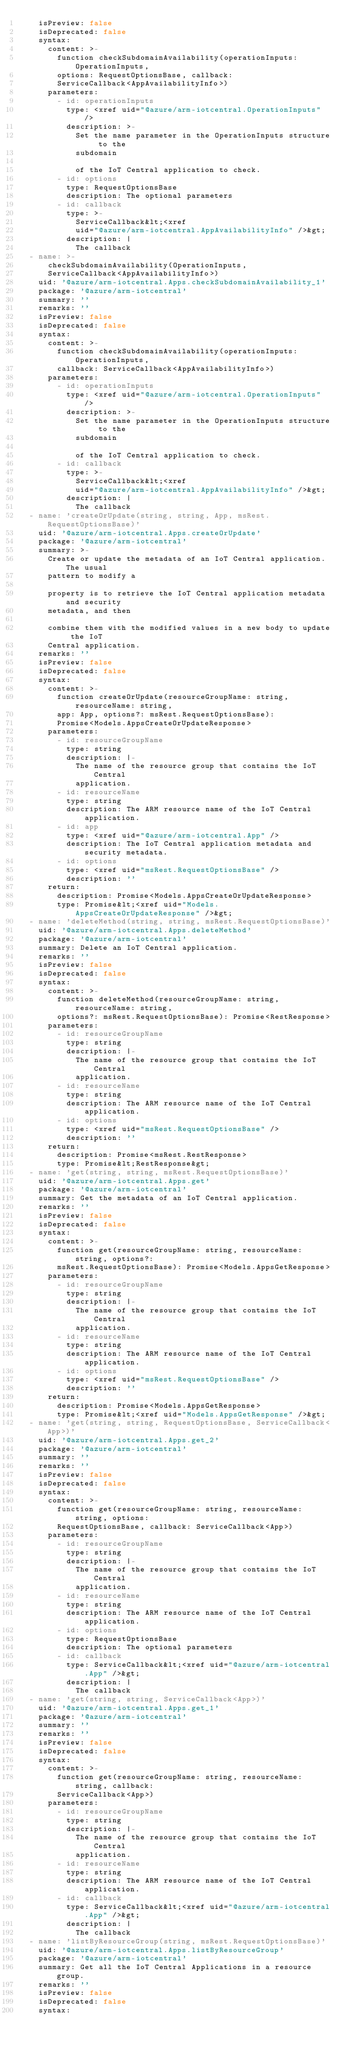Convert code to text. <code><loc_0><loc_0><loc_500><loc_500><_YAML_>    isPreview: false
    isDeprecated: false
    syntax:
      content: >-
        function checkSubdomainAvailability(operationInputs: OperationInputs,
        options: RequestOptionsBase, callback:
        ServiceCallback<AppAvailabilityInfo>)
      parameters:
        - id: operationInputs
          type: <xref uid="@azure/arm-iotcentral.OperationInputs" />
          description: >-
            Set the name parameter in the OperationInputs structure to the
            subdomain

            of the IoT Central application to check.
        - id: options
          type: RequestOptionsBase
          description: The optional parameters
        - id: callback
          type: >-
            ServiceCallback&lt;<xref
            uid="@azure/arm-iotcentral.AppAvailabilityInfo" />&gt;
          description: |
            The callback
  - name: >-
      checkSubdomainAvailability(OperationInputs,
      ServiceCallback<AppAvailabilityInfo>)
    uid: '@azure/arm-iotcentral.Apps.checkSubdomainAvailability_1'
    package: '@azure/arm-iotcentral'
    summary: ''
    remarks: ''
    isPreview: false
    isDeprecated: false
    syntax:
      content: >-
        function checkSubdomainAvailability(operationInputs: OperationInputs,
        callback: ServiceCallback<AppAvailabilityInfo>)
      parameters:
        - id: operationInputs
          type: <xref uid="@azure/arm-iotcentral.OperationInputs" />
          description: >-
            Set the name parameter in the OperationInputs structure to the
            subdomain

            of the IoT Central application to check.
        - id: callback
          type: >-
            ServiceCallback&lt;<xref
            uid="@azure/arm-iotcentral.AppAvailabilityInfo" />&gt;
          description: |
            The callback
  - name: 'createOrUpdate(string, string, App, msRest.RequestOptionsBase)'
    uid: '@azure/arm-iotcentral.Apps.createOrUpdate'
    package: '@azure/arm-iotcentral'
    summary: >-
      Create or update the metadata of an IoT Central application. The usual
      pattern to modify a

      property is to retrieve the IoT Central application metadata and security
      metadata, and then

      combine them with the modified values in a new body to update the IoT
      Central application.
    remarks: ''
    isPreview: false
    isDeprecated: false
    syntax:
      content: >-
        function createOrUpdate(resourceGroupName: string, resourceName: string,
        app: App, options?: msRest.RequestOptionsBase):
        Promise<Models.AppsCreateOrUpdateResponse>
      parameters:
        - id: resourceGroupName
          type: string
          description: |-
            The name of the resource group that contains the IoT Central
            application.
        - id: resourceName
          type: string
          description: The ARM resource name of the IoT Central application.
        - id: app
          type: <xref uid="@azure/arm-iotcentral.App" />
          description: The IoT Central application metadata and security metadata.
        - id: options
          type: <xref uid="msRest.RequestOptionsBase" />
          description: ''
      return:
        description: Promise<Models.AppsCreateOrUpdateResponse>
        type: Promise&lt;<xref uid="Models.AppsCreateOrUpdateResponse" />&gt;
  - name: 'deleteMethod(string, string, msRest.RequestOptionsBase)'
    uid: '@azure/arm-iotcentral.Apps.deleteMethod'
    package: '@azure/arm-iotcentral'
    summary: Delete an IoT Central application.
    remarks: ''
    isPreview: false
    isDeprecated: false
    syntax:
      content: >-
        function deleteMethod(resourceGroupName: string, resourceName: string,
        options?: msRest.RequestOptionsBase): Promise<RestResponse>
      parameters:
        - id: resourceGroupName
          type: string
          description: |-
            The name of the resource group that contains the IoT Central
            application.
        - id: resourceName
          type: string
          description: The ARM resource name of the IoT Central application.
        - id: options
          type: <xref uid="msRest.RequestOptionsBase" />
          description: ''
      return:
        description: Promise<msRest.RestResponse>
        type: Promise&lt;RestResponse&gt;
  - name: 'get(string, string, msRest.RequestOptionsBase)'
    uid: '@azure/arm-iotcentral.Apps.get'
    package: '@azure/arm-iotcentral'
    summary: Get the metadata of an IoT Central application.
    remarks: ''
    isPreview: false
    isDeprecated: false
    syntax:
      content: >-
        function get(resourceGroupName: string, resourceName: string, options?:
        msRest.RequestOptionsBase): Promise<Models.AppsGetResponse>
      parameters:
        - id: resourceGroupName
          type: string
          description: |-
            The name of the resource group that contains the IoT Central
            application.
        - id: resourceName
          type: string
          description: The ARM resource name of the IoT Central application.
        - id: options
          type: <xref uid="msRest.RequestOptionsBase" />
          description: ''
      return:
        description: Promise<Models.AppsGetResponse>
        type: Promise&lt;<xref uid="Models.AppsGetResponse" />&gt;
  - name: 'get(string, string, RequestOptionsBase, ServiceCallback<App>)'
    uid: '@azure/arm-iotcentral.Apps.get_2'
    package: '@azure/arm-iotcentral'
    summary: ''
    remarks: ''
    isPreview: false
    isDeprecated: false
    syntax:
      content: >-
        function get(resourceGroupName: string, resourceName: string, options:
        RequestOptionsBase, callback: ServiceCallback<App>)
      parameters:
        - id: resourceGroupName
          type: string
          description: |-
            The name of the resource group that contains the IoT Central
            application.
        - id: resourceName
          type: string
          description: The ARM resource name of the IoT Central application.
        - id: options
          type: RequestOptionsBase
          description: The optional parameters
        - id: callback
          type: ServiceCallback&lt;<xref uid="@azure/arm-iotcentral.App" />&gt;
          description: |
            The callback
  - name: 'get(string, string, ServiceCallback<App>)'
    uid: '@azure/arm-iotcentral.Apps.get_1'
    package: '@azure/arm-iotcentral'
    summary: ''
    remarks: ''
    isPreview: false
    isDeprecated: false
    syntax:
      content: >-
        function get(resourceGroupName: string, resourceName: string, callback:
        ServiceCallback<App>)
      parameters:
        - id: resourceGroupName
          type: string
          description: |-
            The name of the resource group that contains the IoT Central
            application.
        - id: resourceName
          type: string
          description: The ARM resource name of the IoT Central application.
        - id: callback
          type: ServiceCallback&lt;<xref uid="@azure/arm-iotcentral.App" />&gt;
          description: |
            The callback
  - name: 'listByResourceGroup(string, msRest.RequestOptionsBase)'
    uid: '@azure/arm-iotcentral.Apps.listByResourceGroup'
    package: '@azure/arm-iotcentral'
    summary: Get all the IoT Central Applications in a resource group.
    remarks: ''
    isPreview: false
    isDeprecated: false
    syntax:</code> 